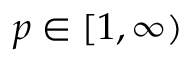<formula> <loc_0><loc_0><loc_500><loc_500>p \in [ 1 , \infty )</formula> 